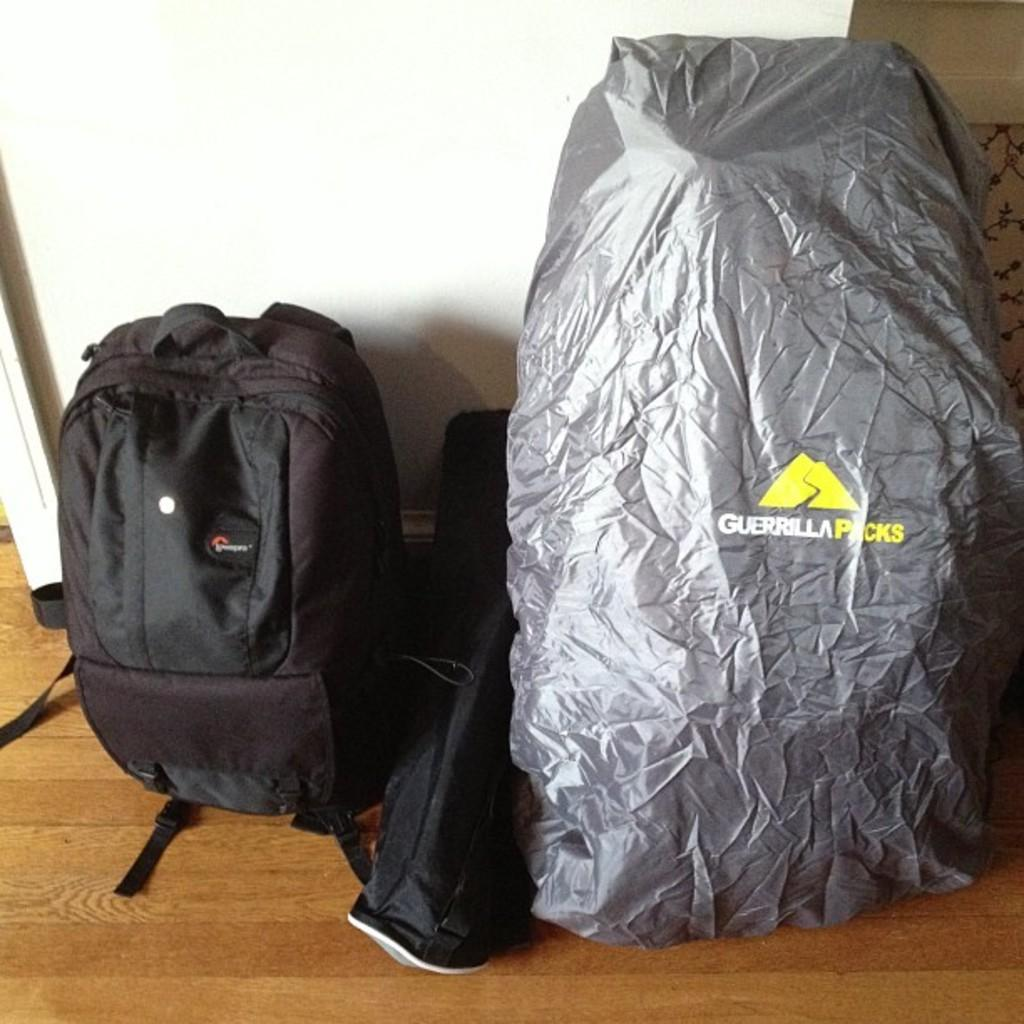<image>
Offer a succinct explanation of the picture presented. a backpack next to something wrapped in a bag that says 'guerrilla packs' on it 